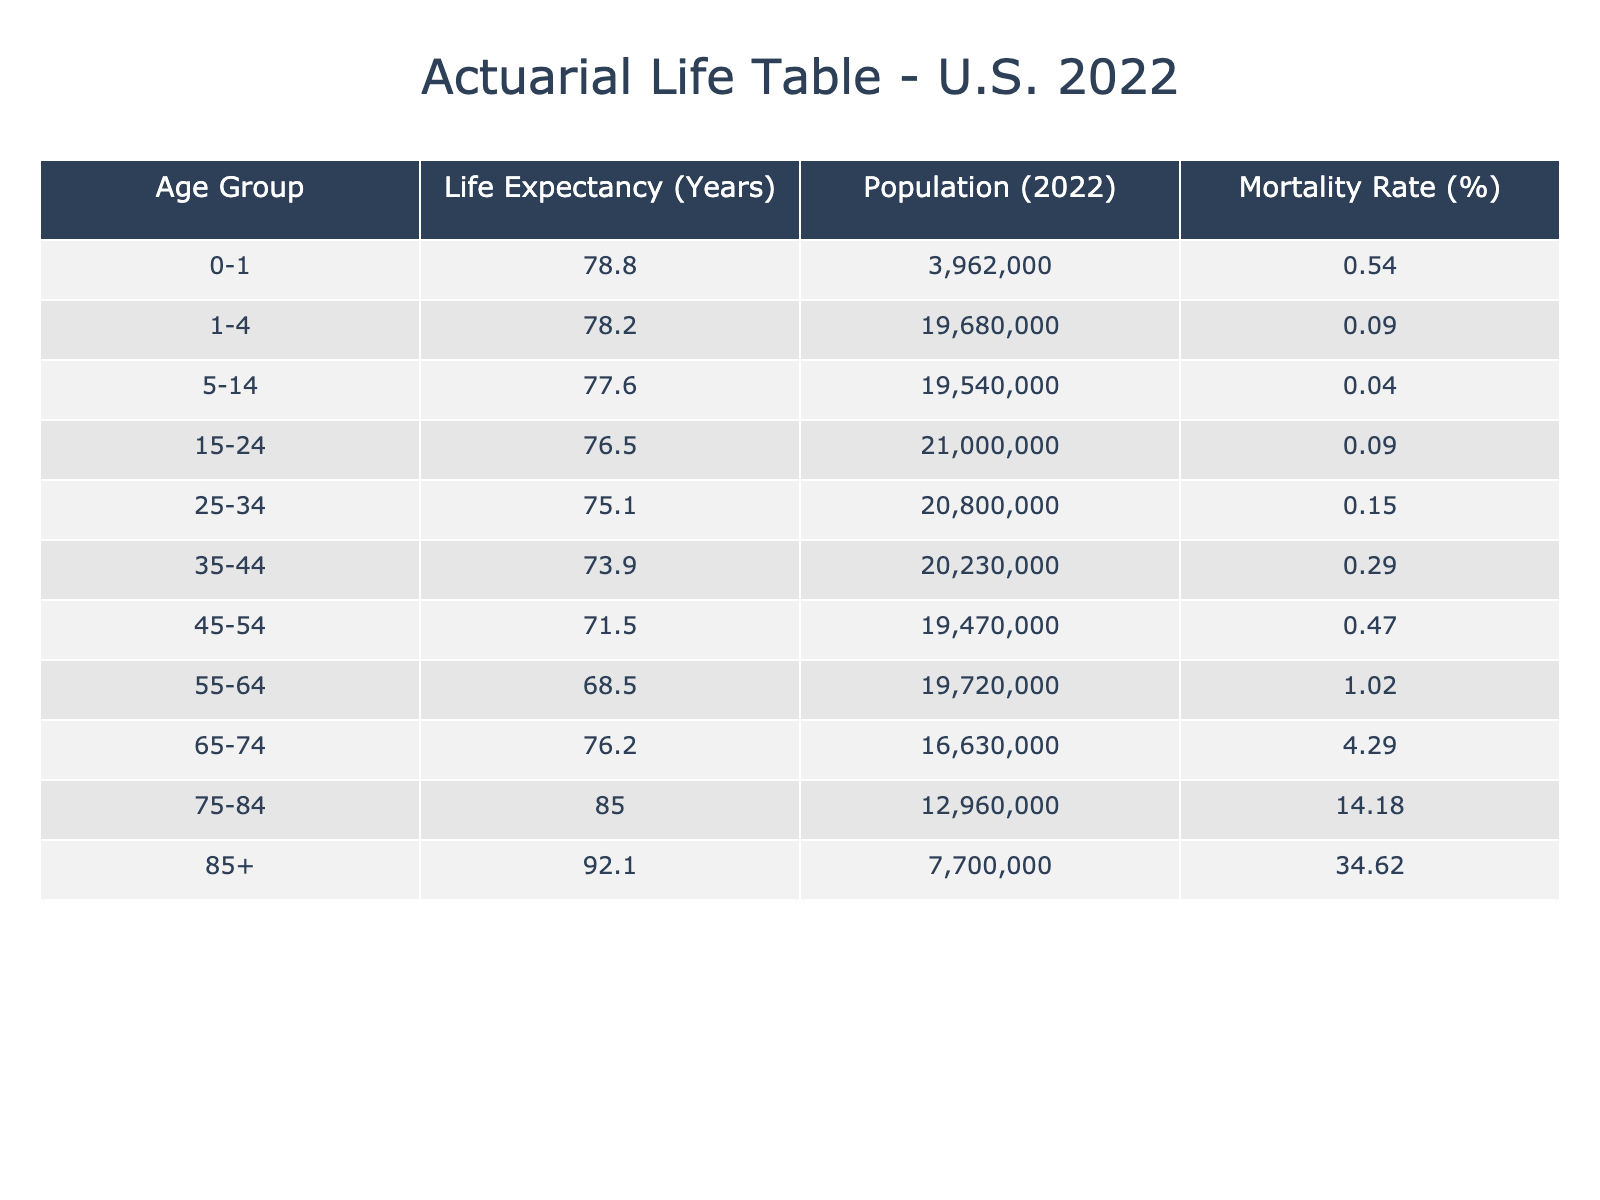What is the life expectancy for the age group 75-84? The table shows that the life expectancy for the age group 75-84 is listed under the "Life Expectancy (Years)" column for that specific age group. Thus, it directly shows the value of 85.0 years.
Answer: 85.0 What is the population of individuals aged 65-74 in 2022? In the table, the population for the age group 65-74 is found in the "Population (2022)" column corresponding to that age group, which indicates it is 16,630,000.
Answer: 16,630,000 Is the mortality rate for the age group 0-1 higher or lower than that for 15-24? To compare both groups, look at the "Mortality Rate (%)" column. The rate for 0-1 is 0.54%, while for 15-24 it is 0.09%. Since 0.54% is greater than 0.09%, the mortality rate for 0-1 is higher.
Answer: Higher Which age group has the highest life expectancy? By examining the "Life Expectancy (Years)" column, the highest value can be found in the 85+ age group, which has a life expectancy of 92.1 years.
Answer: 85+ What is the average life expectancy of the age groups 55-64 and 65-74? To find the average, first identify the life expectancy for both age groups: 55-64 is 68.5 years and 65-74 is 76.2 years. Then, sum these values: 68.5 + 76.2 = 144.7 years. Finally, divide by 2 to get the average: 144.7 / 2 = 72.35 years.
Answer: 72.35 What is the difference in population between the age groups 45-54 and 85+? The population for 45-54 is 19,470,000, and for 85+, it is 7,700,000. To find the difference, subtract the smaller population from the larger: 19,470,000 - 7,700,000 = 11,770,000.
Answer: 11,770,000 Do individuals aged 35-44 have a higher or lower mortality rate than those aged 25-34? In the "Mortality Rate (%)" column, the rate for 35-44 is 0.29% and for 25-34 it is 0.15%. Since 0.29% is greater than 0.15%, individuals aged 35-44 have a higher mortality rate.
Answer: Higher What is the total population for all age groups combined? To find the total population, sum the populations of all the age groups listed in the table: 3,962,000 + 19,680,000 + 19,540,000 + 21,000,000 + 20,800,000 + 20,230,000 + 19,470,000 + 19,720,000 + 16,630,000 + 12,960,000 + 7,700,000 = 25,920,000.
Answer: 25,920,000 Which age group has the lowest life expectancy, and what is that expectancy? The table shows the life expectancy for each age group. The lowest value is found in the 45-54 age group, which has a life expectancy of 71.5 years.
Answer: 71.5 